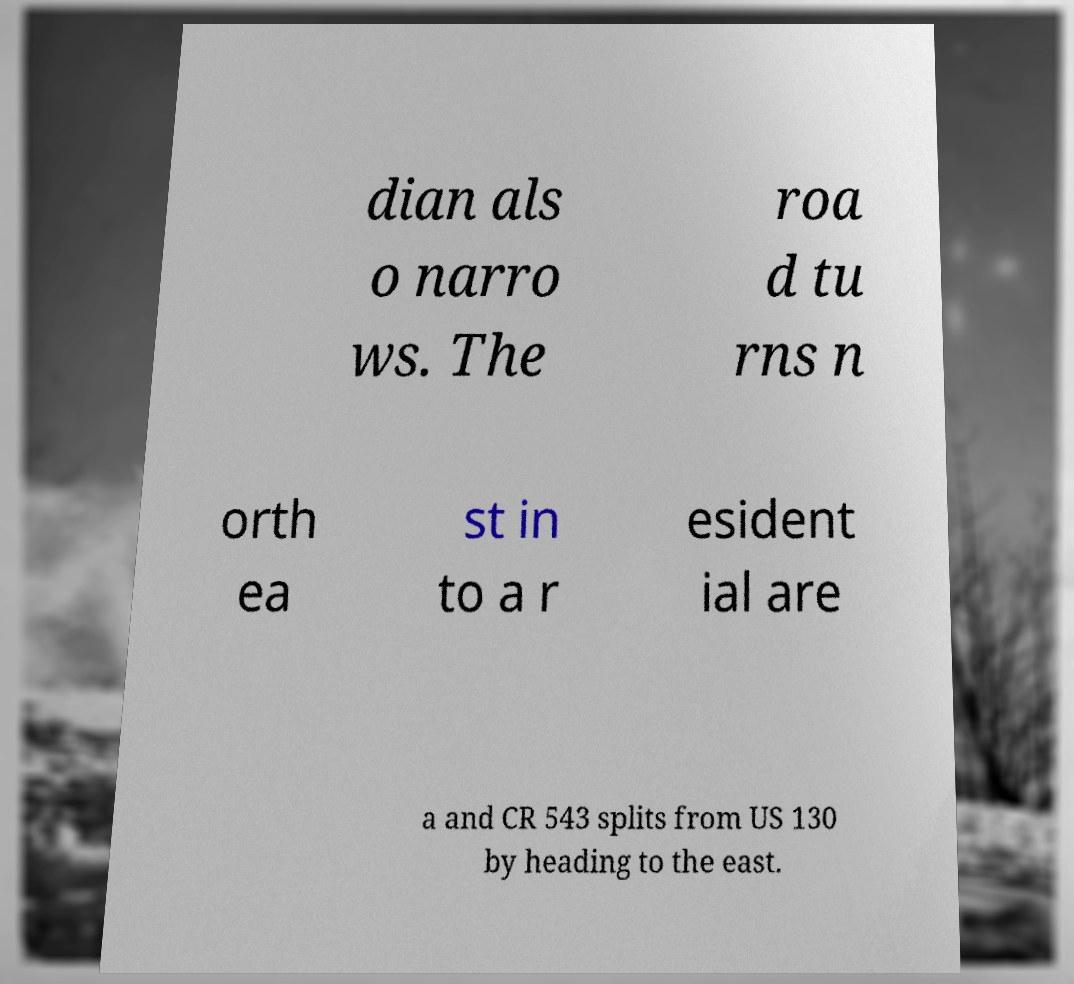There's text embedded in this image that I need extracted. Can you transcribe it verbatim? dian als o narro ws. The roa d tu rns n orth ea st in to a r esident ial are a and CR 543 splits from US 130 by heading to the east. 